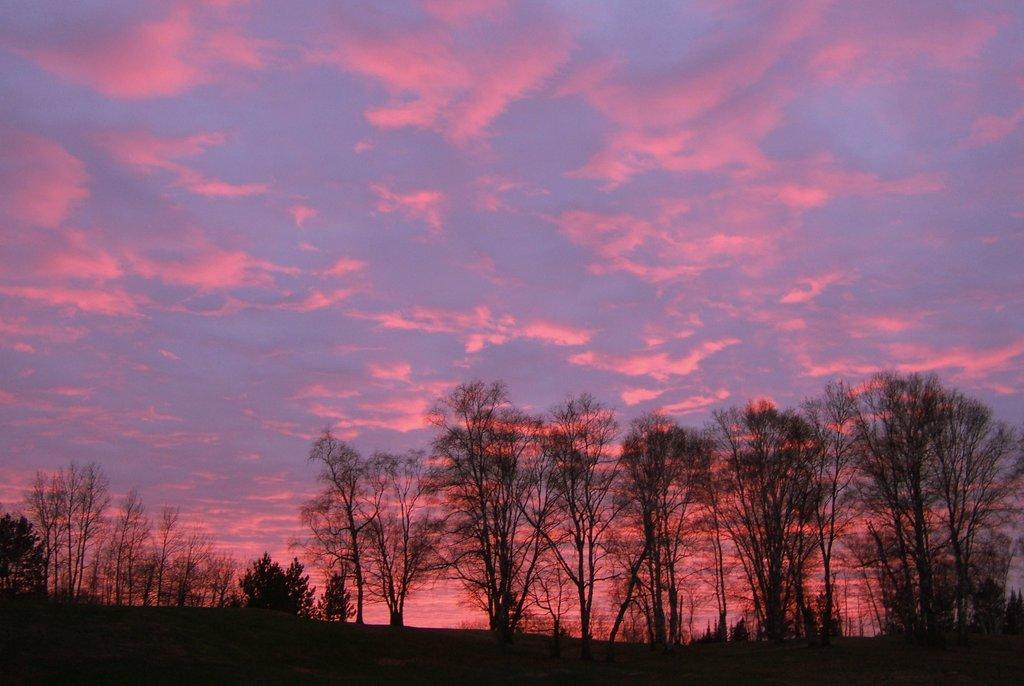What can be seen in the dark area of the image? Trees are present in the dark area of the image. What is visible in the background of the image? The sky is visible in the background of the image. What is the color of the sky in the image? The sky is blue in color. What additional feature can be observed in the sky? Pink clouds are present in the sky. What type of sheet is being used to cover the trees in the image? There is no sheet present in the image; the trees are not covered. What fictional character can be seen interacting with the trees in the image? There are no fictional characters present in the image; it only features trees and the sky. 